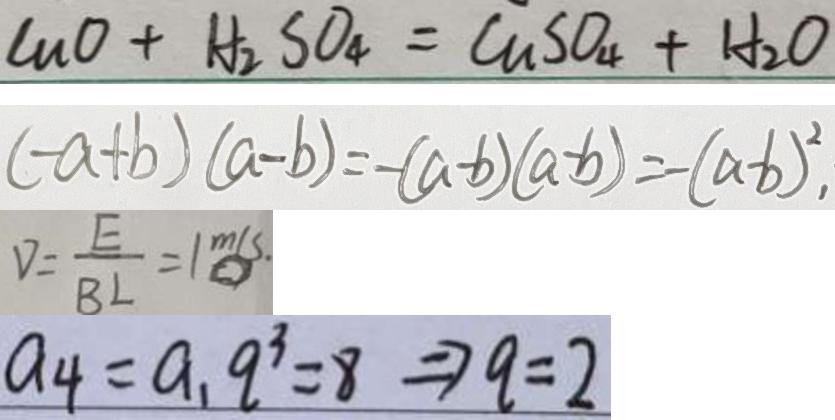<formula> <loc_0><loc_0><loc_500><loc_500>C u O + H _ { 2 } S O _ { 4 } = C u S O _ { 4 } + H _ { 2 } O 
 ( - a + b ) ( a - b ) = - ( a - b ) ( a - b ) = - ( a - b ) ^ { 2 } , 
 V = \frac { E } { B L } = 1 m / s . 
 a _ { 4 } = a _ { 1 } q ^ { 3 } = 8 \Rightarrow q = 2</formula> 